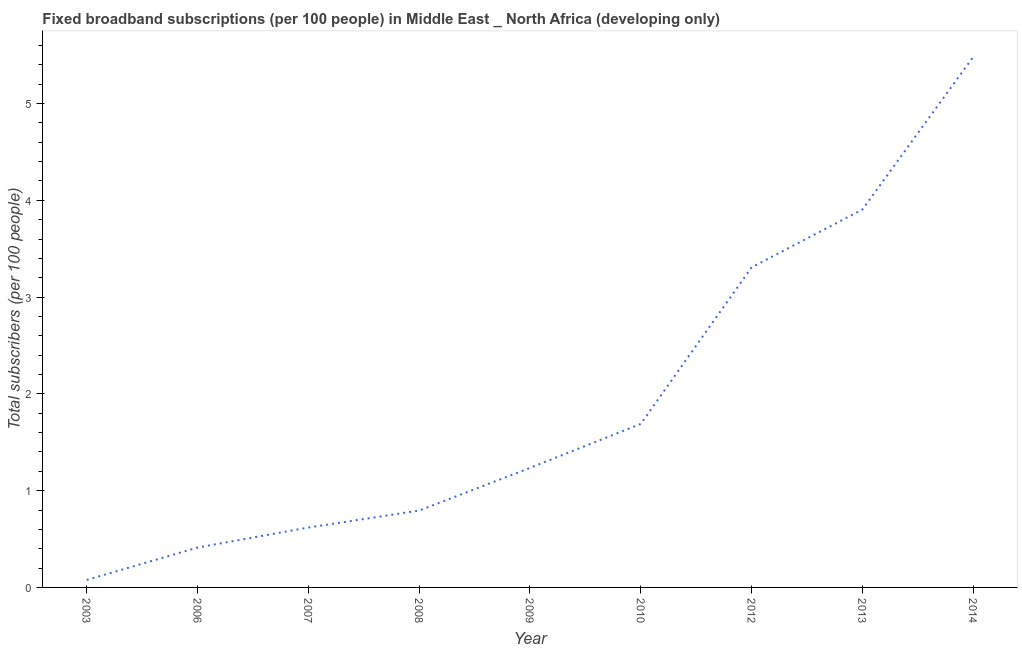What is the total number of fixed broadband subscriptions in 2006?
Your answer should be compact. 0.41. Across all years, what is the maximum total number of fixed broadband subscriptions?
Offer a very short reply. 5.48. Across all years, what is the minimum total number of fixed broadband subscriptions?
Your answer should be compact. 0.08. In which year was the total number of fixed broadband subscriptions minimum?
Ensure brevity in your answer.  2003. What is the sum of the total number of fixed broadband subscriptions?
Provide a short and direct response. 17.52. What is the difference between the total number of fixed broadband subscriptions in 2006 and 2008?
Your answer should be compact. -0.38. What is the average total number of fixed broadband subscriptions per year?
Provide a short and direct response. 1.95. What is the median total number of fixed broadband subscriptions?
Your response must be concise. 1.23. What is the ratio of the total number of fixed broadband subscriptions in 2006 to that in 2014?
Provide a succinct answer. 0.08. What is the difference between the highest and the second highest total number of fixed broadband subscriptions?
Give a very brief answer. 1.58. What is the difference between the highest and the lowest total number of fixed broadband subscriptions?
Offer a terse response. 5.4. In how many years, is the total number of fixed broadband subscriptions greater than the average total number of fixed broadband subscriptions taken over all years?
Your answer should be very brief. 3. Does the total number of fixed broadband subscriptions monotonically increase over the years?
Your answer should be very brief. Yes. What is the title of the graph?
Offer a very short reply. Fixed broadband subscriptions (per 100 people) in Middle East _ North Africa (developing only). What is the label or title of the X-axis?
Your answer should be compact. Year. What is the label or title of the Y-axis?
Offer a very short reply. Total subscribers (per 100 people). What is the Total subscribers (per 100 people) of 2003?
Your answer should be compact. 0.08. What is the Total subscribers (per 100 people) of 2006?
Give a very brief answer. 0.41. What is the Total subscribers (per 100 people) in 2007?
Ensure brevity in your answer.  0.62. What is the Total subscribers (per 100 people) in 2008?
Provide a short and direct response. 0.79. What is the Total subscribers (per 100 people) in 2009?
Give a very brief answer. 1.23. What is the Total subscribers (per 100 people) of 2010?
Offer a terse response. 1.69. What is the Total subscribers (per 100 people) of 2012?
Your answer should be very brief. 3.31. What is the Total subscribers (per 100 people) in 2013?
Your answer should be compact. 3.9. What is the Total subscribers (per 100 people) in 2014?
Your answer should be compact. 5.48. What is the difference between the Total subscribers (per 100 people) in 2003 and 2006?
Ensure brevity in your answer.  -0.33. What is the difference between the Total subscribers (per 100 people) in 2003 and 2007?
Offer a very short reply. -0.54. What is the difference between the Total subscribers (per 100 people) in 2003 and 2008?
Offer a terse response. -0.72. What is the difference between the Total subscribers (per 100 people) in 2003 and 2009?
Offer a terse response. -1.16. What is the difference between the Total subscribers (per 100 people) in 2003 and 2010?
Offer a terse response. -1.61. What is the difference between the Total subscribers (per 100 people) in 2003 and 2012?
Your answer should be compact. -3.23. What is the difference between the Total subscribers (per 100 people) in 2003 and 2013?
Provide a succinct answer. -3.83. What is the difference between the Total subscribers (per 100 people) in 2003 and 2014?
Your response must be concise. -5.4. What is the difference between the Total subscribers (per 100 people) in 2006 and 2007?
Offer a terse response. -0.21. What is the difference between the Total subscribers (per 100 people) in 2006 and 2008?
Your response must be concise. -0.38. What is the difference between the Total subscribers (per 100 people) in 2006 and 2009?
Provide a succinct answer. -0.82. What is the difference between the Total subscribers (per 100 people) in 2006 and 2010?
Make the answer very short. -1.28. What is the difference between the Total subscribers (per 100 people) in 2006 and 2012?
Make the answer very short. -2.89. What is the difference between the Total subscribers (per 100 people) in 2006 and 2013?
Your response must be concise. -3.49. What is the difference between the Total subscribers (per 100 people) in 2006 and 2014?
Give a very brief answer. -5.07. What is the difference between the Total subscribers (per 100 people) in 2007 and 2008?
Make the answer very short. -0.18. What is the difference between the Total subscribers (per 100 people) in 2007 and 2009?
Offer a terse response. -0.62. What is the difference between the Total subscribers (per 100 people) in 2007 and 2010?
Keep it short and to the point. -1.07. What is the difference between the Total subscribers (per 100 people) in 2007 and 2012?
Your answer should be very brief. -2.69. What is the difference between the Total subscribers (per 100 people) in 2007 and 2013?
Ensure brevity in your answer.  -3.29. What is the difference between the Total subscribers (per 100 people) in 2007 and 2014?
Your response must be concise. -4.86. What is the difference between the Total subscribers (per 100 people) in 2008 and 2009?
Offer a very short reply. -0.44. What is the difference between the Total subscribers (per 100 people) in 2008 and 2010?
Make the answer very short. -0.9. What is the difference between the Total subscribers (per 100 people) in 2008 and 2012?
Your response must be concise. -2.51. What is the difference between the Total subscribers (per 100 people) in 2008 and 2013?
Offer a very short reply. -3.11. What is the difference between the Total subscribers (per 100 people) in 2008 and 2014?
Your response must be concise. -4.69. What is the difference between the Total subscribers (per 100 people) in 2009 and 2010?
Make the answer very short. -0.45. What is the difference between the Total subscribers (per 100 people) in 2009 and 2012?
Ensure brevity in your answer.  -2.07. What is the difference between the Total subscribers (per 100 people) in 2009 and 2013?
Keep it short and to the point. -2.67. What is the difference between the Total subscribers (per 100 people) in 2009 and 2014?
Your answer should be compact. -4.25. What is the difference between the Total subscribers (per 100 people) in 2010 and 2012?
Offer a very short reply. -1.62. What is the difference between the Total subscribers (per 100 people) in 2010 and 2013?
Make the answer very short. -2.22. What is the difference between the Total subscribers (per 100 people) in 2010 and 2014?
Give a very brief answer. -3.79. What is the difference between the Total subscribers (per 100 people) in 2012 and 2013?
Provide a succinct answer. -0.6. What is the difference between the Total subscribers (per 100 people) in 2012 and 2014?
Make the answer very short. -2.17. What is the difference between the Total subscribers (per 100 people) in 2013 and 2014?
Give a very brief answer. -1.58. What is the ratio of the Total subscribers (per 100 people) in 2003 to that in 2006?
Provide a short and direct response. 0.19. What is the ratio of the Total subscribers (per 100 people) in 2003 to that in 2007?
Your answer should be compact. 0.12. What is the ratio of the Total subscribers (per 100 people) in 2003 to that in 2008?
Ensure brevity in your answer.  0.1. What is the ratio of the Total subscribers (per 100 people) in 2003 to that in 2009?
Give a very brief answer. 0.06. What is the ratio of the Total subscribers (per 100 people) in 2003 to that in 2010?
Provide a short and direct response. 0.05. What is the ratio of the Total subscribers (per 100 people) in 2003 to that in 2012?
Provide a short and direct response. 0.02. What is the ratio of the Total subscribers (per 100 people) in 2003 to that in 2014?
Offer a terse response. 0.01. What is the ratio of the Total subscribers (per 100 people) in 2006 to that in 2007?
Make the answer very short. 0.67. What is the ratio of the Total subscribers (per 100 people) in 2006 to that in 2008?
Ensure brevity in your answer.  0.52. What is the ratio of the Total subscribers (per 100 people) in 2006 to that in 2009?
Keep it short and to the point. 0.33. What is the ratio of the Total subscribers (per 100 people) in 2006 to that in 2010?
Provide a succinct answer. 0.24. What is the ratio of the Total subscribers (per 100 people) in 2006 to that in 2013?
Provide a succinct answer. 0.11. What is the ratio of the Total subscribers (per 100 people) in 2006 to that in 2014?
Make the answer very short. 0.07. What is the ratio of the Total subscribers (per 100 people) in 2007 to that in 2008?
Make the answer very short. 0.78. What is the ratio of the Total subscribers (per 100 people) in 2007 to that in 2009?
Your answer should be compact. 0.5. What is the ratio of the Total subscribers (per 100 people) in 2007 to that in 2010?
Ensure brevity in your answer.  0.37. What is the ratio of the Total subscribers (per 100 people) in 2007 to that in 2012?
Your answer should be very brief. 0.19. What is the ratio of the Total subscribers (per 100 people) in 2007 to that in 2013?
Make the answer very short. 0.16. What is the ratio of the Total subscribers (per 100 people) in 2007 to that in 2014?
Give a very brief answer. 0.11. What is the ratio of the Total subscribers (per 100 people) in 2008 to that in 2009?
Make the answer very short. 0.64. What is the ratio of the Total subscribers (per 100 people) in 2008 to that in 2010?
Make the answer very short. 0.47. What is the ratio of the Total subscribers (per 100 people) in 2008 to that in 2012?
Provide a short and direct response. 0.24. What is the ratio of the Total subscribers (per 100 people) in 2008 to that in 2013?
Your answer should be very brief. 0.2. What is the ratio of the Total subscribers (per 100 people) in 2008 to that in 2014?
Ensure brevity in your answer.  0.14. What is the ratio of the Total subscribers (per 100 people) in 2009 to that in 2010?
Your answer should be very brief. 0.73. What is the ratio of the Total subscribers (per 100 people) in 2009 to that in 2012?
Offer a very short reply. 0.37. What is the ratio of the Total subscribers (per 100 people) in 2009 to that in 2013?
Provide a succinct answer. 0.32. What is the ratio of the Total subscribers (per 100 people) in 2009 to that in 2014?
Your answer should be very brief. 0.23. What is the ratio of the Total subscribers (per 100 people) in 2010 to that in 2012?
Your response must be concise. 0.51. What is the ratio of the Total subscribers (per 100 people) in 2010 to that in 2013?
Provide a succinct answer. 0.43. What is the ratio of the Total subscribers (per 100 people) in 2010 to that in 2014?
Offer a terse response. 0.31. What is the ratio of the Total subscribers (per 100 people) in 2012 to that in 2013?
Your answer should be very brief. 0.85. What is the ratio of the Total subscribers (per 100 people) in 2012 to that in 2014?
Offer a terse response. 0.6. What is the ratio of the Total subscribers (per 100 people) in 2013 to that in 2014?
Give a very brief answer. 0.71. 